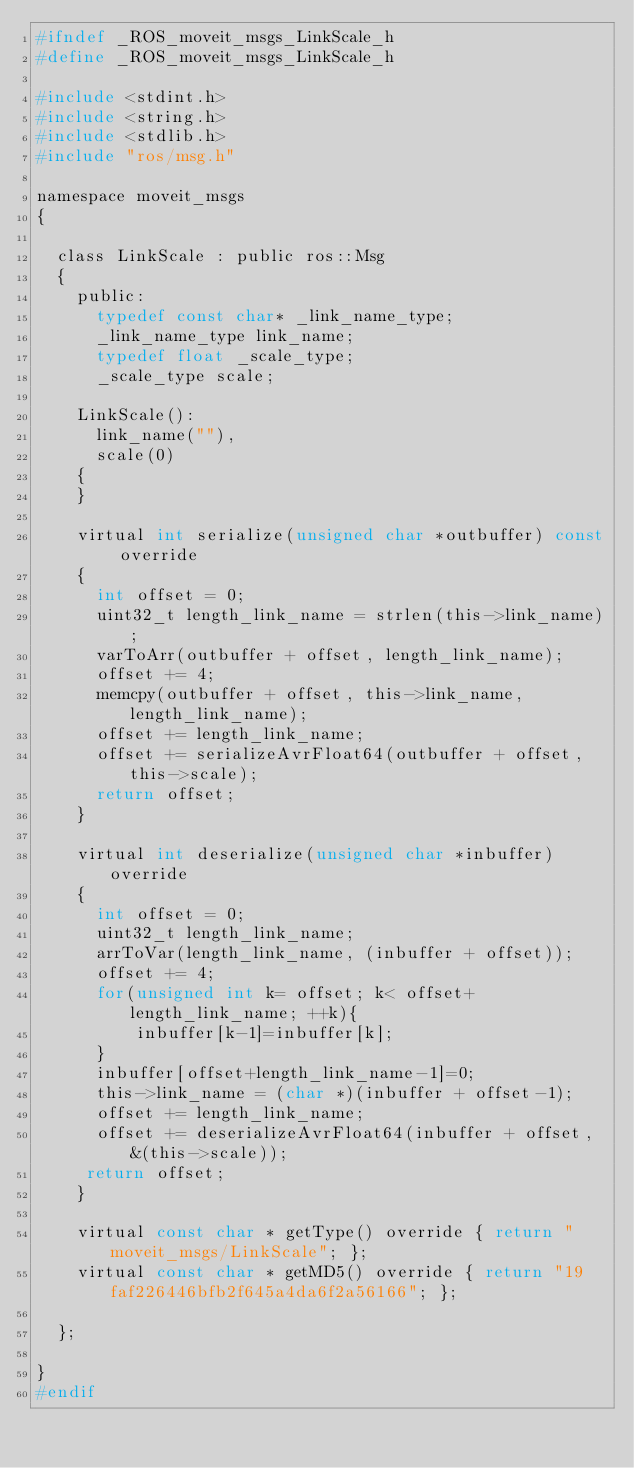Convert code to text. <code><loc_0><loc_0><loc_500><loc_500><_C_>#ifndef _ROS_moveit_msgs_LinkScale_h
#define _ROS_moveit_msgs_LinkScale_h

#include <stdint.h>
#include <string.h>
#include <stdlib.h>
#include "ros/msg.h"

namespace moveit_msgs
{

  class LinkScale : public ros::Msg
  {
    public:
      typedef const char* _link_name_type;
      _link_name_type link_name;
      typedef float _scale_type;
      _scale_type scale;

    LinkScale():
      link_name(""),
      scale(0)
    {
    }

    virtual int serialize(unsigned char *outbuffer) const override
    {
      int offset = 0;
      uint32_t length_link_name = strlen(this->link_name);
      varToArr(outbuffer + offset, length_link_name);
      offset += 4;
      memcpy(outbuffer + offset, this->link_name, length_link_name);
      offset += length_link_name;
      offset += serializeAvrFloat64(outbuffer + offset, this->scale);
      return offset;
    }

    virtual int deserialize(unsigned char *inbuffer) override
    {
      int offset = 0;
      uint32_t length_link_name;
      arrToVar(length_link_name, (inbuffer + offset));
      offset += 4;
      for(unsigned int k= offset; k< offset+length_link_name; ++k){
          inbuffer[k-1]=inbuffer[k];
      }
      inbuffer[offset+length_link_name-1]=0;
      this->link_name = (char *)(inbuffer + offset-1);
      offset += length_link_name;
      offset += deserializeAvrFloat64(inbuffer + offset, &(this->scale));
     return offset;
    }

    virtual const char * getType() override { return "moveit_msgs/LinkScale"; };
    virtual const char * getMD5() override { return "19faf226446bfb2f645a4da6f2a56166"; };

  };

}
#endif
</code> 